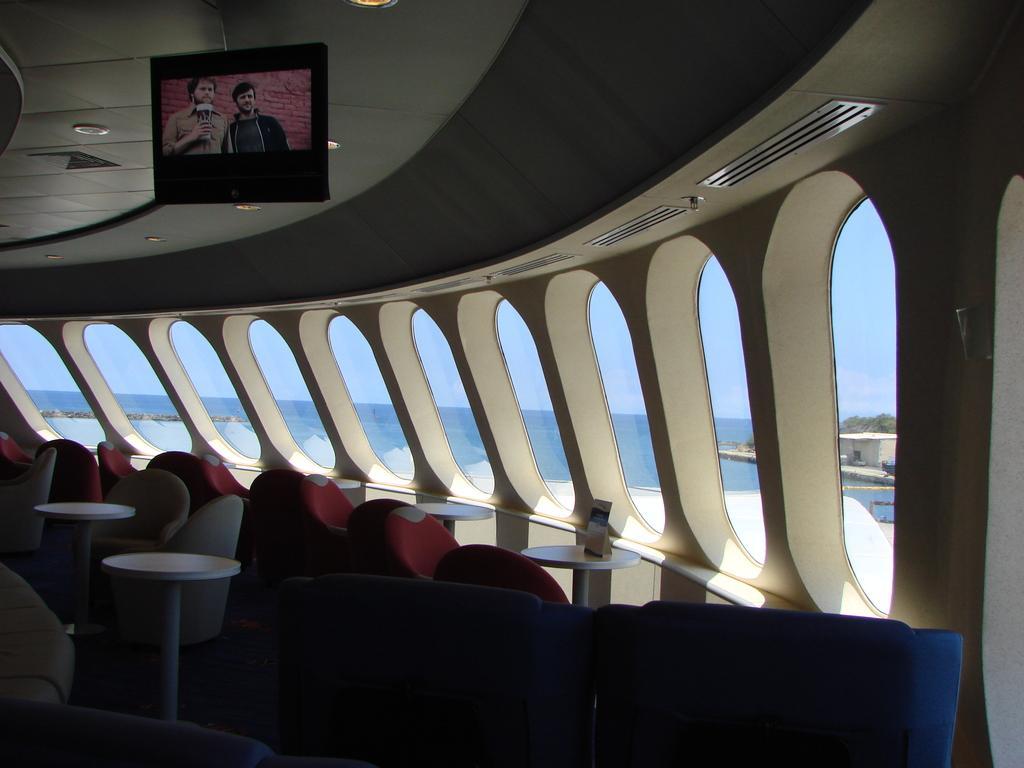Can you describe this image briefly? In this image, I can see a television, which is hanging. I think this picture was taken inside the building. These are the chairs and tables. I can see the windows with the glass doors. I can see the water and a small house through the windows. 